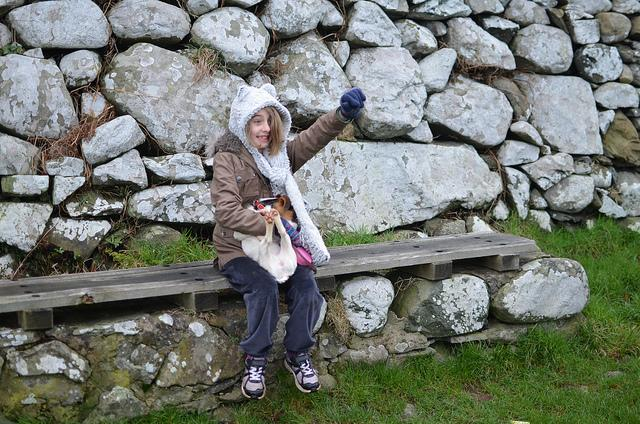What is it called when walls are built without mortar? dry stack 